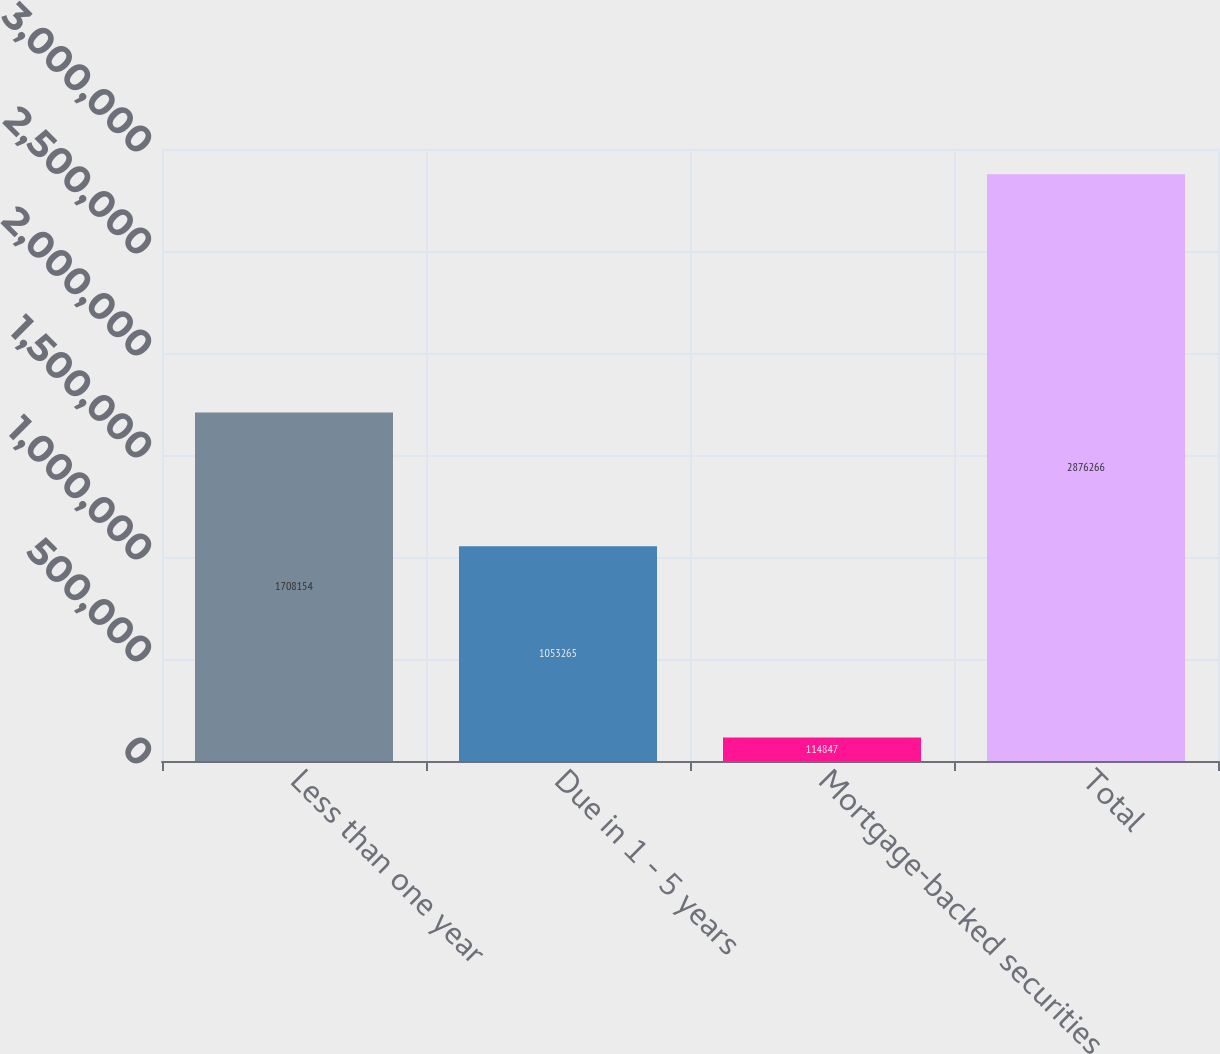<chart> <loc_0><loc_0><loc_500><loc_500><bar_chart><fcel>Less than one year<fcel>Due in 1 - 5 years<fcel>Mortgage-backed securities<fcel>Total<nl><fcel>1.70815e+06<fcel>1.05326e+06<fcel>114847<fcel>2.87627e+06<nl></chart> 